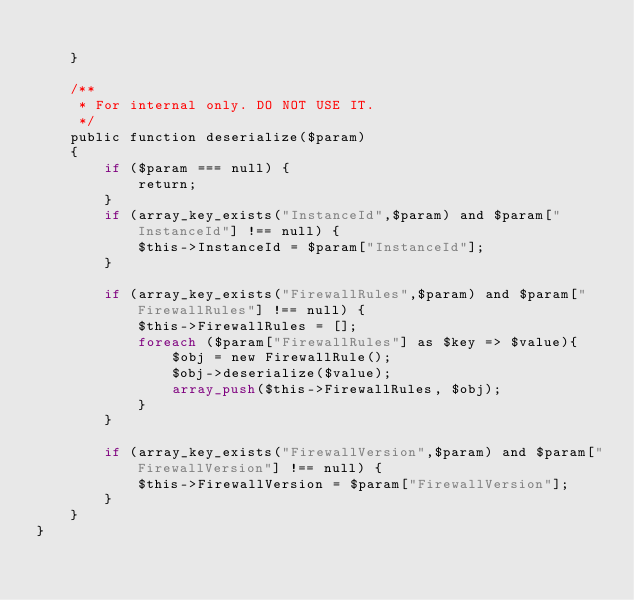<code> <loc_0><loc_0><loc_500><loc_500><_PHP_>
    }

    /**
     * For internal only. DO NOT USE IT.
     */
    public function deserialize($param)
    {
        if ($param === null) {
            return;
        }
        if (array_key_exists("InstanceId",$param) and $param["InstanceId"] !== null) {
            $this->InstanceId = $param["InstanceId"];
        }

        if (array_key_exists("FirewallRules",$param) and $param["FirewallRules"] !== null) {
            $this->FirewallRules = [];
            foreach ($param["FirewallRules"] as $key => $value){
                $obj = new FirewallRule();
                $obj->deserialize($value);
                array_push($this->FirewallRules, $obj);
            }
        }

        if (array_key_exists("FirewallVersion",$param) and $param["FirewallVersion"] !== null) {
            $this->FirewallVersion = $param["FirewallVersion"];
        }
    }
}
</code> 